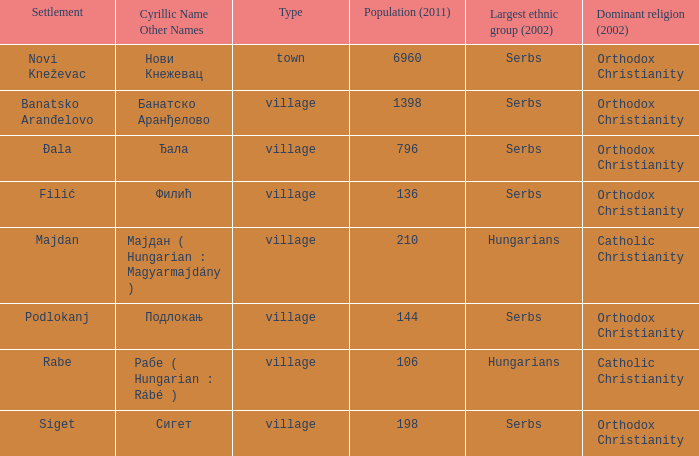What place is referred to by the cyrillic name сигет? Siget. 